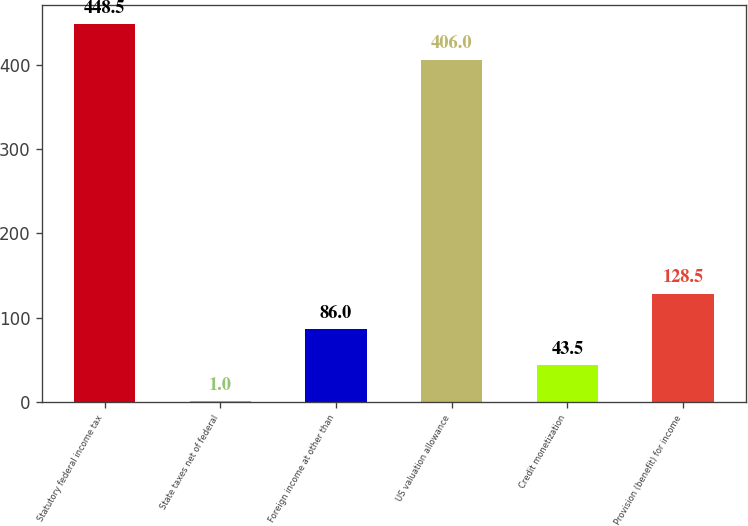Convert chart. <chart><loc_0><loc_0><loc_500><loc_500><bar_chart><fcel>Statutory federal income tax<fcel>State taxes net of federal<fcel>Foreign income at other than<fcel>US valuation allowance<fcel>Credit monetization<fcel>Provision (benefit) for income<nl><fcel>448.5<fcel>1<fcel>86<fcel>406<fcel>43.5<fcel>128.5<nl></chart> 